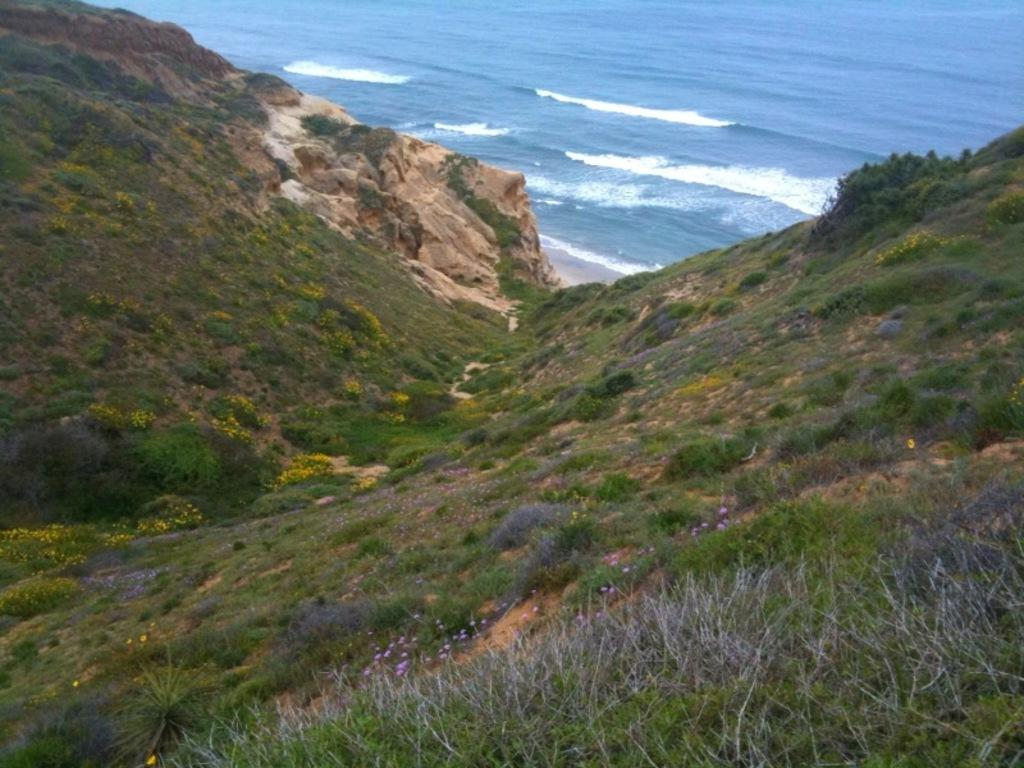Where was the image taken from? The image is taken from outside the city. What type of vegetation can be seen in the image? There are trees, plants, and flowers in the image. What is the ground surface like in the image? There is grass and rocks present in the image. What can be seen in the background of the image? There is water visible in the background, which appears to be an ocean. What story is being told by the books in the image? There are no books present in the image. What part of the human body is visible in the image? There is no part of the human body visible in the image. 